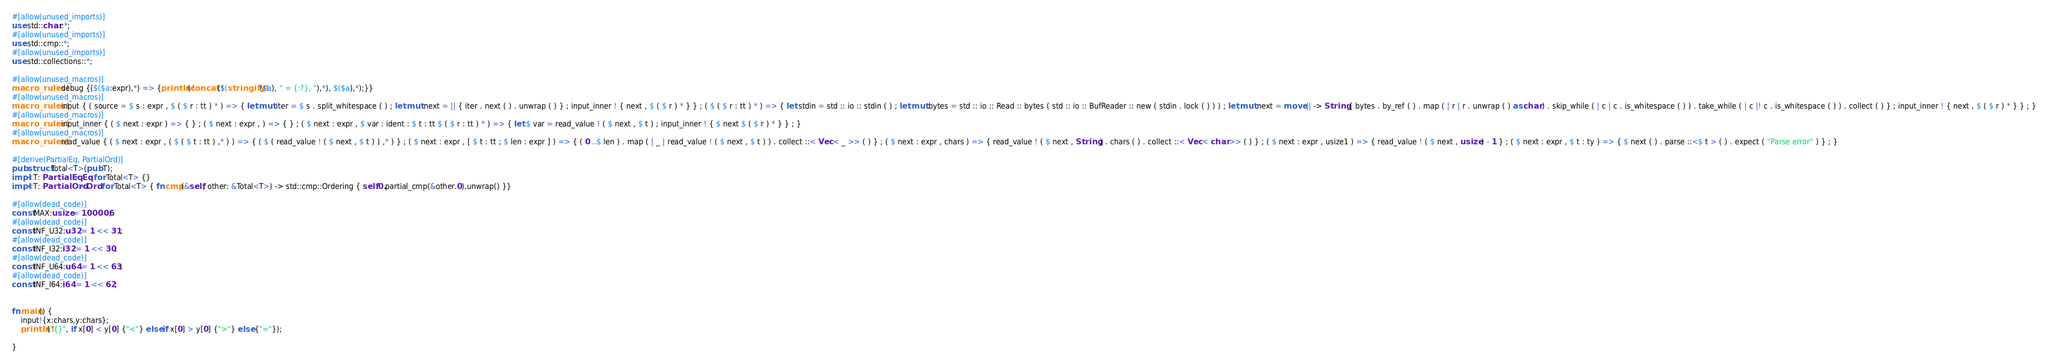<code> <loc_0><loc_0><loc_500><loc_500><_Rust_>#[allow(unused_imports)]
use std::char::*;
#[allow(unused_imports)]
use std::cmp::*;
#[allow(unused_imports)]
use std::collections::*;

#[allow(unused_macros)]
macro_rules! debug {($($a:expr),*) => {println!(concat!($(stringify!($a), " = {:?}, "),*), $($a),*);}}
#[allow(unused_macros)]
macro_rules! input { ( source = $ s : expr , $ ( $ r : tt ) * ) => { let mut iter = $ s . split_whitespace ( ) ; let mut next = || { iter . next ( ) . unwrap ( ) } ; input_inner ! { next , $ ( $ r ) * } } ; ( $ ( $ r : tt ) * ) => { let stdin = std :: io :: stdin ( ) ; let mut bytes = std :: io :: Read :: bytes ( std :: io :: BufReader :: new ( stdin . lock ( ) ) ) ; let mut next = move || -> String { bytes . by_ref ( ) . map ( | r | r . unwrap ( ) as char ) . skip_while ( | c | c . is_whitespace ( ) ) . take_while ( | c |! c . is_whitespace ( ) ) . collect ( ) } ; input_inner ! { next , $ ( $ r ) * } } ; }
#[allow(unused_macros)]
macro_rules! input_inner { ( $ next : expr ) => { } ; ( $ next : expr , ) => { } ; ( $ next : expr , $ var : ident : $ t : tt $ ( $ r : tt ) * ) => { let $ var = read_value ! ( $ next , $ t ) ; input_inner ! { $ next $ ( $ r ) * } } ; }
#[allow(unused_macros)]
macro_rules! read_value { ( $ next : expr , ( $ ( $ t : tt ) ,* ) ) => { ( $ ( read_value ! ( $ next , $ t ) ) ,* ) } ; ( $ next : expr , [ $ t : tt ; $ len : expr ] ) => { ( 0 ..$ len ) . map ( | _ | read_value ! ( $ next , $ t ) ) . collect ::< Vec < _ >> ( ) } ; ( $ next : expr , chars ) => { read_value ! ( $ next , String ) . chars ( ) . collect ::< Vec < char >> ( ) } ; ( $ next : expr , usize1 ) => { read_value ! ( $ next , usize ) - 1 } ; ( $ next : expr , $ t : ty ) => { $ next ( ) . parse ::<$ t > ( ) . expect ( "Parse error" ) } ; }

#[derive(PartialEq, PartialOrd)]
pub struct Total<T>(pub T);
impl<T: PartialEq> Eq for Total<T> {}
impl<T: PartialOrd> Ord for Total<T> { fn cmp(&self, other: &Total<T>) -> std::cmp::Ordering { self.0.partial_cmp(&other.0).unwrap() }}

#[allow(dead_code)]
const MAX:usize = 100006;
#[allow(dead_code)]
const INF_U32:u32 = 1 << 31;
#[allow(dead_code)]
const INF_I32:i32 = 1 << 30;
#[allow(dead_code)]
const INF_U64:u64 = 1 << 63;
#[allow(dead_code)]
const INF_I64:i64 = 1 << 62;


fn main() {
    input!{x:chars,y:chars};
    println!("{}", if x[0] < y[0] {"<"} else if x[0] > y[0] {">"} else {"="});

}</code> 